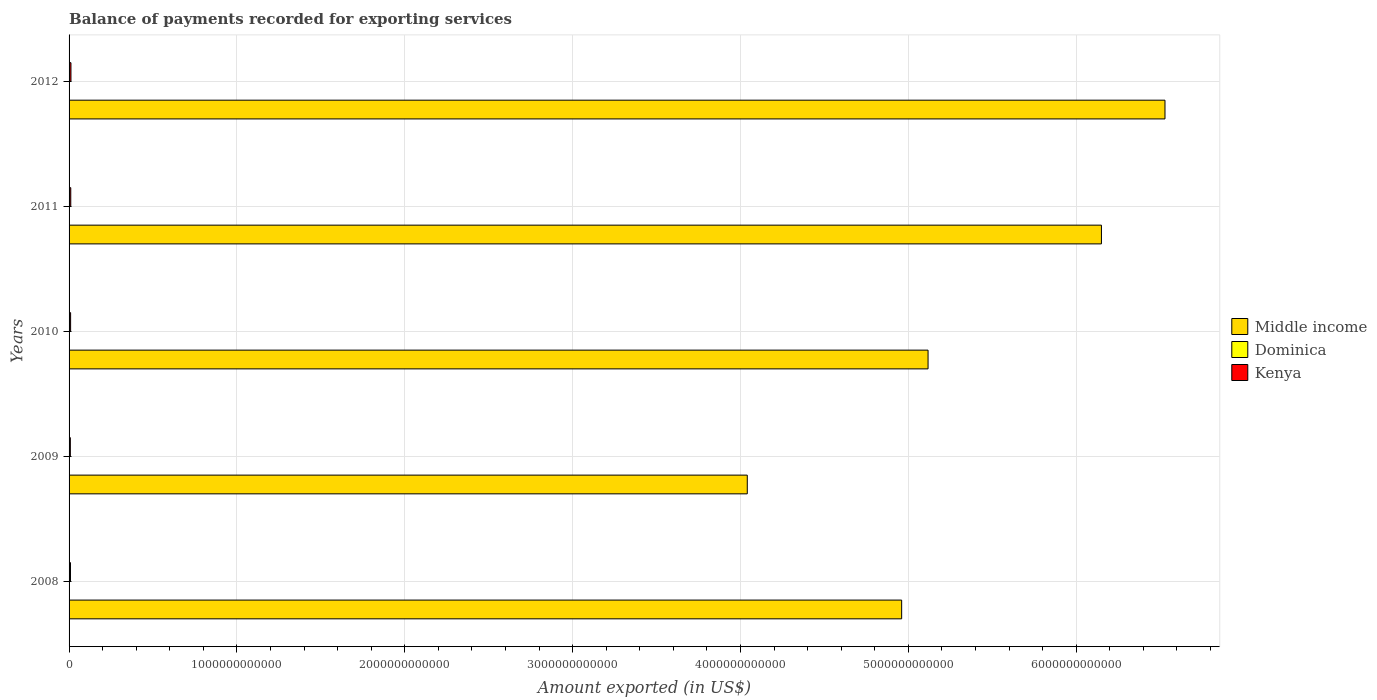How many groups of bars are there?
Keep it short and to the point. 5. Are the number of bars per tick equal to the number of legend labels?
Offer a very short reply. Yes. Are the number of bars on each tick of the Y-axis equal?
Ensure brevity in your answer.  Yes. How many bars are there on the 4th tick from the top?
Make the answer very short. 3. How many bars are there on the 3rd tick from the bottom?
Give a very brief answer. 3. What is the amount exported in Kenya in 2009?
Offer a terse response. 7.57e+09. Across all years, what is the maximum amount exported in Kenya?
Offer a very short reply. 1.12e+1. Across all years, what is the minimum amount exported in Kenya?
Your response must be concise. 7.57e+09. In which year was the amount exported in Kenya minimum?
Provide a succinct answer. 2009. What is the total amount exported in Dominica in the graph?
Give a very brief answer. 8.61e+08. What is the difference between the amount exported in Kenya in 2010 and that in 2011?
Your answer should be very brief. -1.00e+09. What is the difference between the amount exported in Middle income in 2011 and the amount exported in Dominica in 2012?
Ensure brevity in your answer.  6.15e+12. What is the average amount exported in Dominica per year?
Your response must be concise. 1.72e+08. In the year 2008, what is the difference between the amount exported in Kenya and amount exported in Dominica?
Give a very brief answer. 8.30e+09. What is the ratio of the amount exported in Dominica in 2010 to that in 2012?
Your answer should be very brief. 1.09. What is the difference between the highest and the second highest amount exported in Kenya?
Your response must be concise. 1.08e+09. What is the difference between the highest and the lowest amount exported in Middle income?
Keep it short and to the point. 2.49e+12. Is the sum of the amount exported in Middle income in 2008 and 2012 greater than the maximum amount exported in Dominica across all years?
Offer a very short reply. Yes. What does the 1st bar from the top in 2009 represents?
Make the answer very short. Kenya. What does the 2nd bar from the bottom in 2009 represents?
Ensure brevity in your answer.  Dominica. Is it the case that in every year, the sum of the amount exported in Kenya and amount exported in Middle income is greater than the amount exported in Dominica?
Give a very brief answer. Yes. How many bars are there?
Offer a very short reply. 15. Are all the bars in the graph horizontal?
Give a very brief answer. Yes. How many years are there in the graph?
Provide a short and direct response. 5. What is the difference between two consecutive major ticks on the X-axis?
Offer a very short reply. 1.00e+12. Does the graph contain any zero values?
Provide a succinct answer. No. Does the graph contain grids?
Ensure brevity in your answer.  Yes. Where does the legend appear in the graph?
Offer a very short reply. Center right. How are the legend labels stacked?
Your answer should be very brief. Vertical. What is the title of the graph?
Your answer should be very brief. Balance of payments recorded for exporting services. Does "Solomon Islands" appear as one of the legend labels in the graph?
Give a very brief answer. No. What is the label or title of the X-axis?
Your answer should be compact. Amount exported (in US$). What is the label or title of the Y-axis?
Your response must be concise. Years. What is the Amount exported (in US$) of Middle income in 2008?
Ensure brevity in your answer.  4.96e+12. What is the Amount exported (in US$) of Dominica in 2008?
Your response must be concise. 1.65e+08. What is the Amount exported (in US$) of Kenya in 2008?
Provide a succinct answer. 8.47e+09. What is the Amount exported (in US$) in Middle income in 2009?
Keep it short and to the point. 4.04e+12. What is the Amount exported (in US$) of Dominica in 2009?
Offer a terse response. 1.55e+08. What is the Amount exported (in US$) of Kenya in 2009?
Provide a succinct answer. 7.57e+09. What is the Amount exported (in US$) in Middle income in 2010?
Your response must be concise. 5.12e+12. What is the Amount exported (in US$) in Dominica in 2010?
Give a very brief answer. 1.80e+08. What is the Amount exported (in US$) of Kenya in 2010?
Your response must be concise. 9.13e+09. What is the Amount exported (in US$) of Middle income in 2011?
Ensure brevity in your answer.  6.15e+12. What is the Amount exported (in US$) in Dominica in 2011?
Offer a terse response. 1.96e+08. What is the Amount exported (in US$) of Kenya in 2011?
Make the answer very short. 1.01e+1. What is the Amount exported (in US$) of Middle income in 2012?
Your answer should be very brief. 6.53e+12. What is the Amount exported (in US$) in Dominica in 2012?
Offer a terse response. 1.65e+08. What is the Amount exported (in US$) of Kenya in 2012?
Give a very brief answer. 1.12e+1. Across all years, what is the maximum Amount exported (in US$) in Middle income?
Provide a succinct answer. 6.53e+12. Across all years, what is the maximum Amount exported (in US$) of Dominica?
Your answer should be compact. 1.96e+08. Across all years, what is the maximum Amount exported (in US$) in Kenya?
Ensure brevity in your answer.  1.12e+1. Across all years, what is the minimum Amount exported (in US$) of Middle income?
Provide a short and direct response. 4.04e+12. Across all years, what is the minimum Amount exported (in US$) of Dominica?
Keep it short and to the point. 1.55e+08. Across all years, what is the minimum Amount exported (in US$) in Kenya?
Your answer should be compact. 7.57e+09. What is the total Amount exported (in US$) of Middle income in the graph?
Ensure brevity in your answer.  2.68e+13. What is the total Amount exported (in US$) of Dominica in the graph?
Make the answer very short. 8.61e+08. What is the total Amount exported (in US$) in Kenya in the graph?
Keep it short and to the point. 4.65e+1. What is the difference between the Amount exported (in US$) of Middle income in 2008 and that in 2009?
Ensure brevity in your answer.  9.20e+11. What is the difference between the Amount exported (in US$) of Dominica in 2008 and that in 2009?
Offer a very short reply. 1.06e+07. What is the difference between the Amount exported (in US$) in Kenya in 2008 and that in 2009?
Offer a terse response. 9.00e+08. What is the difference between the Amount exported (in US$) in Middle income in 2008 and that in 2010?
Provide a succinct answer. -1.57e+11. What is the difference between the Amount exported (in US$) of Dominica in 2008 and that in 2010?
Keep it short and to the point. -1.50e+07. What is the difference between the Amount exported (in US$) of Kenya in 2008 and that in 2010?
Your answer should be very brief. -6.61e+08. What is the difference between the Amount exported (in US$) of Middle income in 2008 and that in 2011?
Make the answer very short. -1.19e+12. What is the difference between the Amount exported (in US$) of Dominica in 2008 and that in 2011?
Provide a succinct answer. -3.07e+07. What is the difference between the Amount exported (in US$) of Kenya in 2008 and that in 2011?
Your response must be concise. -1.66e+09. What is the difference between the Amount exported (in US$) in Middle income in 2008 and that in 2012?
Your answer should be very brief. -1.57e+12. What is the difference between the Amount exported (in US$) in Dominica in 2008 and that in 2012?
Provide a succinct answer. 1.01e+05. What is the difference between the Amount exported (in US$) of Kenya in 2008 and that in 2012?
Your answer should be very brief. -2.74e+09. What is the difference between the Amount exported (in US$) of Middle income in 2009 and that in 2010?
Provide a succinct answer. -1.08e+12. What is the difference between the Amount exported (in US$) of Dominica in 2009 and that in 2010?
Your answer should be very brief. -2.56e+07. What is the difference between the Amount exported (in US$) in Kenya in 2009 and that in 2010?
Provide a succinct answer. -1.56e+09. What is the difference between the Amount exported (in US$) in Middle income in 2009 and that in 2011?
Your answer should be very brief. -2.11e+12. What is the difference between the Amount exported (in US$) of Dominica in 2009 and that in 2011?
Offer a terse response. -4.14e+07. What is the difference between the Amount exported (in US$) of Kenya in 2009 and that in 2011?
Provide a succinct answer. -2.56e+09. What is the difference between the Amount exported (in US$) of Middle income in 2009 and that in 2012?
Provide a short and direct response. -2.49e+12. What is the difference between the Amount exported (in US$) of Dominica in 2009 and that in 2012?
Provide a succinct answer. -1.05e+07. What is the difference between the Amount exported (in US$) in Kenya in 2009 and that in 2012?
Keep it short and to the point. -3.64e+09. What is the difference between the Amount exported (in US$) in Middle income in 2010 and that in 2011?
Your answer should be very brief. -1.03e+12. What is the difference between the Amount exported (in US$) of Dominica in 2010 and that in 2011?
Offer a terse response. -1.57e+07. What is the difference between the Amount exported (in US$) of Kenya in 2010 and that in 2011?
Provide a short and direct response. -1.00e+09. What is the difference between the Amount exported (in US$) in Middle income in 2010 and that in 2012?
Make the answer very short. -1.41e+12. What is the difference between the Amount exported (in US$) of Dominica in 2010 and that in 2012?
Provide a short and direct response. 1.51e+07. What is the difference between the Amount exported (in US$) in Kenya in 2010 and that in 2012?
Your response must be concise. -2.08e+09. What is the difference between the Amount exported (in US$) in Middle income in 2011 and that in 2012?
Give a very brief answer. -3.79e+11. What is the difference between the Amount exported (in US$) in Dominica in 2011 and that in 2012?
Give a very brief answer. 3.08e+07. What is the difference between the Amount exported (in US$) in Kenya in 2011 and that in 2012?
Ensure brevity in your answer.  -1.08e+09. What is the difference between the Amount exported (in US$) of Middle income in 2008 and the Amount exported (in US$) of Dominica in 2009?
Provide a short and direct response. 4.96e+12. What is the difference between the Amount exported (in US$) in Middle income in 2008 and the Amount exported (in US$) in Kenya in 2009?
Offer a very short reply. 4.95e+12. What is the difference between the Amount exported (in US$) of Dominica in 2008 and the Amount exported (in US$) of Kenya in 2009?
Keep it short and to the point. -7.40e+09. What is the difference between the Amount exported (in US$) in Middle income in 2008 and the Amount exported (in US$) in Dominica in 2010?
Your answer should be compact. 4.96e+12. What is the difference between the Amount exported (in US$) of Middle income in 2008 and the Amount exported (in US$) of Kenya in 2010?
Your response must be concise. 4.95e+12. What is the difference between the Amount exported (in US$) of Dominica in 2008 and the Amount exported (in US$) of Kenya in 2010?
Ensure brevity in your answer.  -8.96e+09. What is the difference between the Amount exported (in US$) in Middle income in 2008 and the Amount exported (in US$) in Dominica in 2011?
Make the answer very short. 4.96e+12. What is the difference between the Amount exported (in US$) in Middle income in 2008 and the Amount exported (in US$) in Kenya in 2011?
Provide a short and direct response. 4.95e+12. What is the difference between the Amount exported (in US$) of Dominica in 2008 and the Amount exported (in US$) of Kenya in 2011?
Provide a short and direct response. -9.96e+09. What is the difference between the Amount exported (in US$) of Middle income in 2008 and the Amount exported (in US$) of Dominica in 2012?
Make the answer very short. 4.96e+12. What is the difference between the Amount exported (in US$) of Middle income in 2008 and the Amount exported (in US$) of Kenya in 2012?
Offer a terse response. 4.95e+12. What is the difference between the Amount exported (in US$) of Dominica in 2008 and the Amount exported (in US$) of Kenya in 2012?
Provide a succinct answer. -1.10e+1. What is the difference between the Amount exported (in US$) in Middle income in 2009 and the Amount exported (in US$) in Dominica in 2010?
Ensure brevity in your answer.  4.04e+12. What is the difference between the Amount exported (in US$) of Middle income in 2009 and the Amount exported (in US$) of Kenya in 2010?
Offer a terse response. 4.03e+12. What is the difference between the Amount exported (in US$) in Dominica in 2009 and the Amount exported (in US$) in Kenya in 2010?
Ensure brevity in your answer.  -8.97e+09. What is the difference between the Amount exported (in US$) in Middle income in 2009 and the Amount exported (in US$) in Dominica in 2011?
Offer a very short reply. 4.04e+12. What is the difference between the Amount exported (in US$) of Middle income in 2009 and the Amount exported (in US$) of Kenya in 2011?
Your answer should be very brief. 4.03e+12. What is the difference between the Amount exported (in US$) in Dominica in 2009 and the Amount exported (in US$) in Kenya in 2011?
Offer a terse response. -9.98e+09. What is the difference between the Amount exported (in US$) in Middle income in 2009 and the Amount exported (in US$) in Dominica in 2012?
Ensure brevity in your answer.  4.04e+12. What is the difference between the Amount exported (in US$) in Middle income in 2009 and the Amount exported (in US$) in Kenya in 2012?
Ensure brevity in your answer.  4.03e+12. What is the difference between the Amount exported (in US$) in Dominica in 2009 and the Amount exported (in US$) in Kenya in 2012?
Ensure brevity in your answer.  -1.11e+1. What is the difference between the Amount exported (in US$) of Middle income in 2010 and the Amount exported (in US$) of Dominica in 2011?
Keep it short and to the point. 5.12e+12. What is the difference between the Amount exported (in US$) in Middle income in 2010 and the Amount exported (in US$) in Kenya in 2011?
Provide a short and direct response. 5.11e+12. What is the difference between the Amount exported (in US$) of Dominica in 2010 and the Amount exported (in US$) of Kenya in 2011?
Your response must be concise. -9.95e+09. What is the difference between the Amount exported (in US$) in Middle income in 2010 and the Amount exported (in US$) in Dominica in 2012?
Offer a very short reply. 5.12e+12. What is the difference between the Amount exported (in US$) in Middle income in 2010 and the Amount exported (in US$) in Kenya in 2012?
Provide a short and direct response. 5.11e+12. What is the difference between the Amount exported (in US$) of Dominica in 2010 and the Amount exported (in US$) of Kenya in 2012?
Give a very brief answer. -1.10e+1. What is the difference between the Amount exported (in US$) in Middle income in 2011 and the Amount exported (in US$) in Dominica in 2012?
Provide a succinct answer. 6.15e+12. What is the difference between the Amount exported (in US$) of Middle income in 2011 and the Amount exported (in US$) of Kenya in 2012?
Your answer should be compact. 6.14e+12. What is the difference between the Amount exported (in US$) in Dominica in 2011 and the Amount exported (in US$) in Kenya in 2012?
Make the answer very short. -1.10e+1. What is the average Amount exported (in US$) in Middle income per year?
Your answer should be very brief. 5.36e+12. What is the average Amount exported (in US$) of Dominica per year?
Offer a terse response. 1.72e+08. What is the average Amount exported (in US$) of Kenya per year?
Provide a succinct answer. 9.30e+09. In the year 2008, what is the difference between the Amount exported (in US$) of Middle income and Amount exported (in US$) of Dominica?
Keep it short and to the point. 4.96e+12. In the year 2008, what is the difference between the Amount exported (in US$) in Middle income and Amount exported (in US$) in Kenya?
Your response must be concise. 4.95e+12. In the year 2008, what is the difference between the Amount exported (in US$) of Dominica and Amount exported (in US$) of Kenya?
Your answer should be very brief. -8.30e+09. In the year 2009, what is the difference between the Amount exported (in US$) in Middle income and Amount exported (in US$) in Dominica?
Offer a terse response. 4.04e+12. In the year 2009, what is the difference between the Amount exported (in US$) of Middle income and Amount exported (in US$) of Kenya?
Your response must be concise. 4.03e+12. In the year 2009, what is the difference between the Amount exported (in US$) of Dominica and Amount exported (in US$) of Kenya?
Make the answer very short. -7.41e+09. In the year 2010, what is the difference between the Amount exported (in US$) of Middle income and Amount exported (in US$) of Dominica?
Make the answer very short. 5.12e+12. In the year 2010, what is the difference between the Amount exported (in US$) of Middle income and Amount exported (in US$) of Kenya?
Make the answer very short. 5.11e+12. In the year 2010, what is the difference between the Amount exported (in US$) in Dominica and Amount exported (in US$) in Kenya?
Your answer should be very brief. -8.95e+09. In the year 2011, what is the difference between the Amount exported (in US$) of Middle income and Amount exported (in US$) of Dominica?
Keep it short and to the point. 6.15e+12. In the year 2011, what is the difference between the Amount exported (in US$) of Middle income and Amount exported (in US$) of Kenya?
Keep it short and to the point. 6.14e+12. In the year 2011, what is the difference between the Amount exported (in US$) in Dominica and Amount exported (in US$) in Kenya?
Provide a short and direct response. -9.93e+09. In the year 2012, what is the difference between the Amount exported (in US$) of Middle income and Amount exported (in US$) of Dominica?
Make the answer very short. 6.53e+12. In the year 2012, what is the difference between the Amount exported (in US$) in Middle income and Amount exported (in US$) in Kenya?
Your answer should be compact. 6.52e+12. In the year 2012, what is the difference between the Amount exported (in US$) of Dominica and Amount exported (in US$) of Kenya?
Offer a very short reply. -1.10e+1. What is the ratio of the Amount exported (in US$) in Middle income in 2008 to that in 2009?
Give a very brief answer. 1.23. What is the ratio of the Amount exported (in US$) of Dominica in 2008 to that in 2009?
Ensure brevity in your answer.  1.07. What is the ratio of the Amount exported (in US$) of Kenya in 2008 to that in 2009?
Make the answer very short. 1.12. What is the ratio of the Amount exported (in US$) of Middle income in 2008 to that in 2010?
Provide a succinct answer. 0.97. What is the ratio of the Amount exported (in US$) in Dominica in 2008 to that in 2010?
Offer a very short reply. 0.92. What is the ratio of the Amount exported (in US$) of Kenya in 2008 to that in 2010?
Your answer should be compact. 0.93. What is the ratio of the Amount exported (in US$) in Middle income in 2008 to that in 2011?
Ensure brevity in your answer.  0.81. What is the ratio of the Amount exported (in US$) of Dominica in 2008 to that in 2011?
Provide a succinct answer. 0.84. What is the ratio of the Amount exported (in US$) of Kenya in 2008 to that in 2011?
Give a very brief answer. 0.84. What is the ratio of the Amount exported (in US$) of Middle income in 2008 to that in 2012?
Your answer should be very brief. 0.76. What is the ratio of the Amount exported (in US$) in Dominica in 2008 to that in 2012?
Make the answer very short. 1. What is the ratio of the Amount exported (in US$) of Kenya in 2008 to that in 2012?
Keep it short and to the point. 0.76. What is the ratio of the Amount exported (in US$) in Middle income in 2009 to that in 2010?
Your answer should be very brief. 0.79. What is the ratio of the Amount exported (in US$) of Dominica in 2009 to that in 2010?
Ensure brevity in your answer.  0.86. What is the ratio of the Amount exported (in US$) of Kenya in 2009 to that in 2010?
Provide a succinct answer. 0.83. What is the ratio of the Amount exported (in US$) of Middle income in 2009 to that in 2011?
Make the answer very short. 0.66. What is the ratio of the Amount exported (in US$) of Dominica in 2009 to that in 2011?
Provide a succinct answer. 0.79. What is the ratio of the Amount exported (in US$) of Kenya in 2009 to that in 2011?
Ensure brevity in your answer.  0.75. What is the ratio of the Amount exported (in US$) of Middle income in 2009 to that in 2012?
Your answer should be very brief. 0.62. What is the ratio of the Amount exported (in US$) of Dominica in 2009 to that in 2012?
Provide a short and direct response. 0.94. What is the ratio of the Amount exported (in US$) in Kenya in 2009 to that in 2012?
Offer a terse response. 0.68. What is the ratio of the Amount exported (in US$) of Middle income in 2010 to that in 2011?
Your answer should be very brief. 0.83. What is the ratio of the Amount exported (in US$) of Dominica in 2010 to that in 2011?
Offer a very short reply. 0.92. What is the ratio of the Amount exported (in US$) in Kenya in 2010 to that in 2011?
Provide a short and direct response. 0.9. What is the ratio of the Amount exported (in US$) in Middle income in 2010 to that in 2012?
Give a very brief answer. 0.78. What is the ratio of the Amount exported (in US$) of Dominica in 2010 to that in 2012?
Your answer should be compact. 1.09. What is the ratio of the Amount exported (in US$) in Kenya in 2010 to that in 2012?
Offer a very short reply. 0.81. What is the ratio of the Amount exported (in US$) of Middle income in 2011 to that in 2012?
Give a very brief answer. 0.94. What is the ratio of the Amount exported (in US$) in Dominica in 2011 to that in 2012?
Provide a succinct answer. 1.19. What is the ratio of the Amount exported (in US$) in Kenya in 2011 to that in 2012?
Keep it short and to the point. 0.9. What is the difference between the highest and the second highest Amount exported (in US$) of Middle income?
Your answer should be compact. 3.79e+11. What is the difference between the highest and the second highest Amount exported (in US$) of Dominica?
Your response must be concise. 1.57e+07. What is the difference between the highest and the second highest Amount exported (in US$) of Kenya?
Ensure brevity in your answer.  1.08e+09. What is the difference between the highest and the lowest Amount exported (in US$) of Middle income?
Provide a succinct answer. 2.49e+12. What is the difference between the highest and the lowest Amount exported (in US$) of Dominica?
Give a very brief answer. 4.14e+07. What is the difference between the highest and the lowest Amount exported (in US$) in Kenya?
Your answer should be very brief. 3.64e+09. 